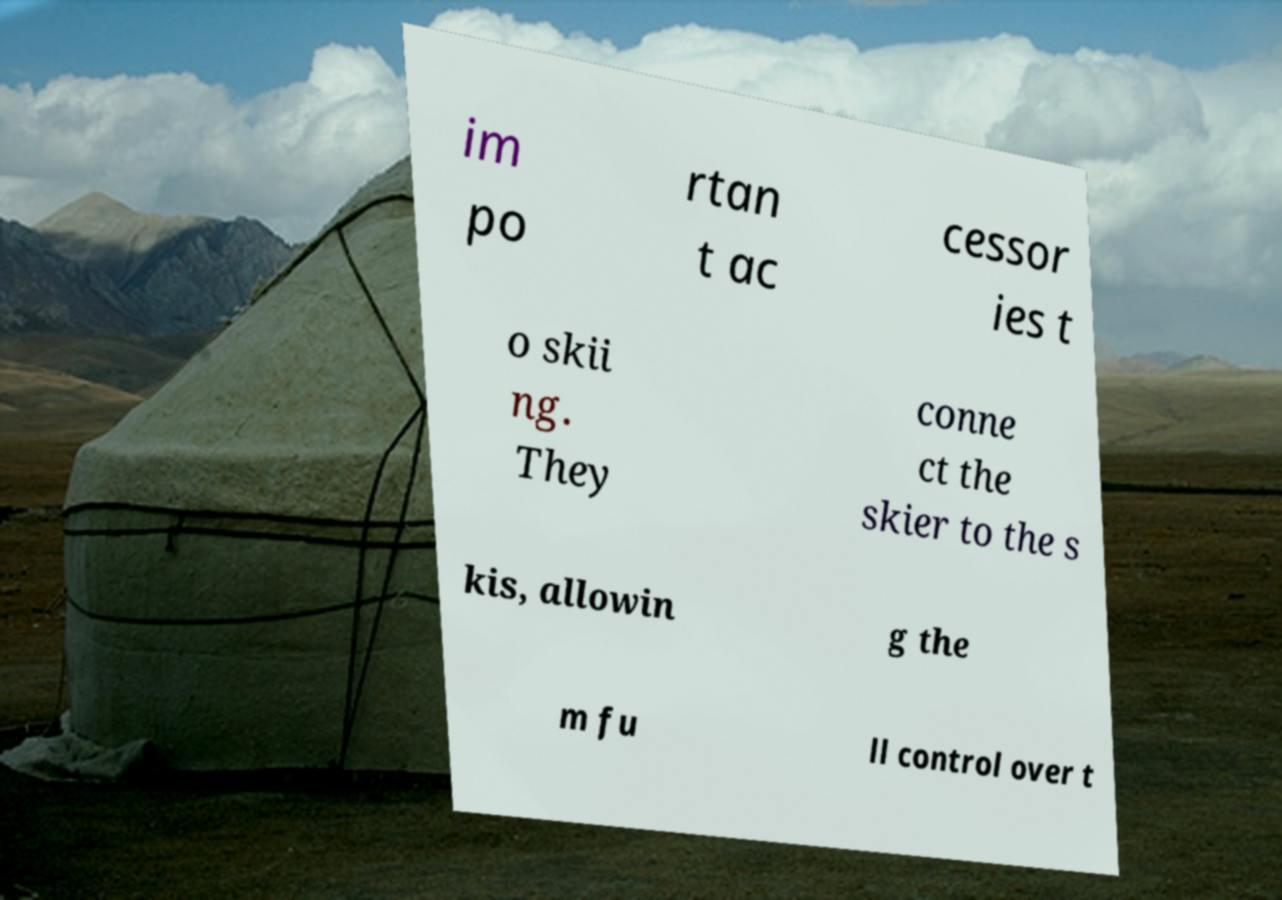Can you accurately transcribe the text from the provided image for me? im po rtan t ac cessor ies t o skii ng. They conne ct the skier to the s kis, allowin g the m fu ll control over t 